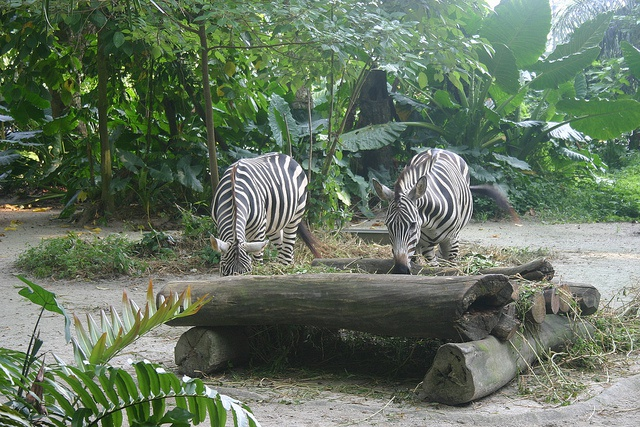Describe the objects in this image and their specific colors. I can see zebra in teal, gray, darkgray, lightgray, and black tones and zebra in teal, gray, darkgray, lightgray, and black tones in this image. 